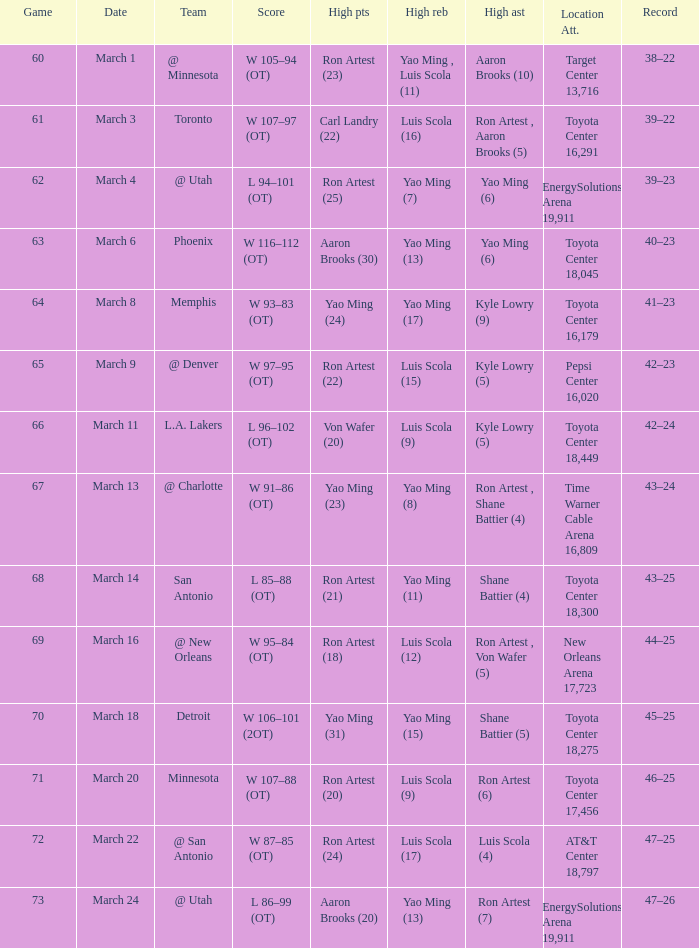In game 72, who scored the highest number of points? Ron Artest (24). 